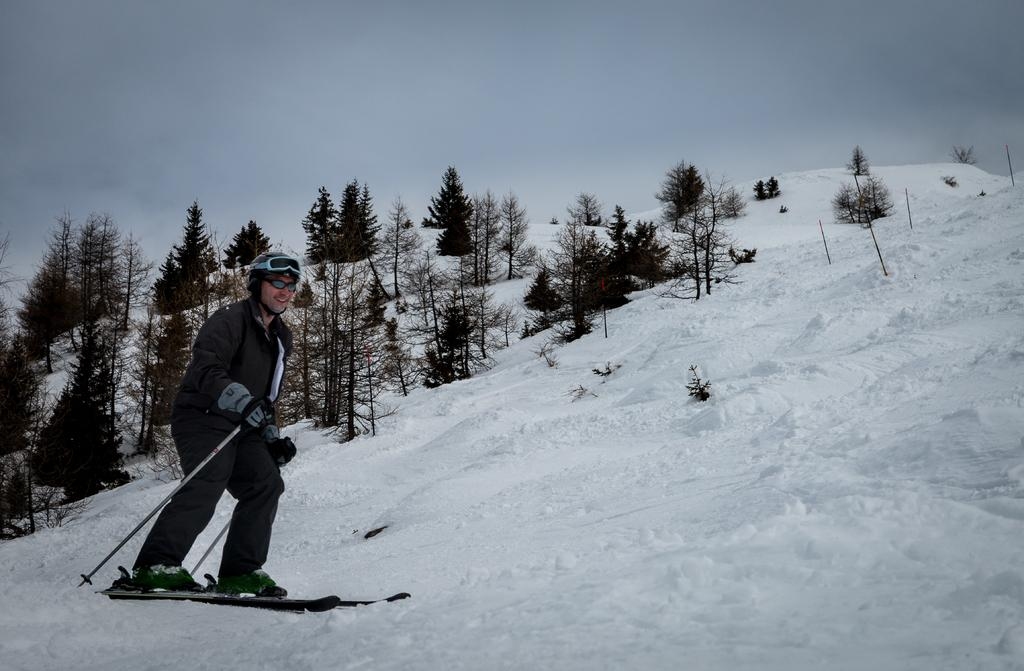What is the main subject of the image? There is a person in the image. What is the person doing in the image? The person is standing on skateboards on the snow. What is the person holding in his hands? The person is holding sticks in his hands. What can be seen in the background of the image? There are trees visible in the background of the image. Can you see a sail in the image? There is no sail present in the image. 